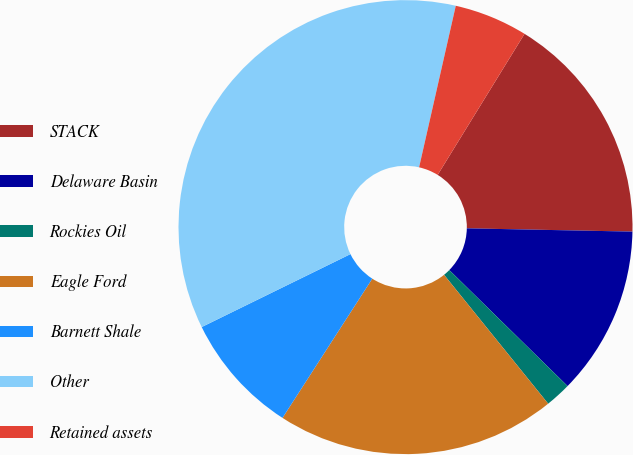<chart> <loc_0><loc_0><loc_500><loc_500><pie_chart><fcel>STACK<fcel>Delaware Basin<fcel>Rockies Oil<fcel>Eagle Ford<fcel>Barnett Shale<fcel>Other<fcel>Retained assets<nl><fcel>16.53%<fcel>12.03%<fcel>1.84%<fcel>19.93%<fcel>8.63%<fcel>35.81%<fcel>5.23%<nl></chart> 